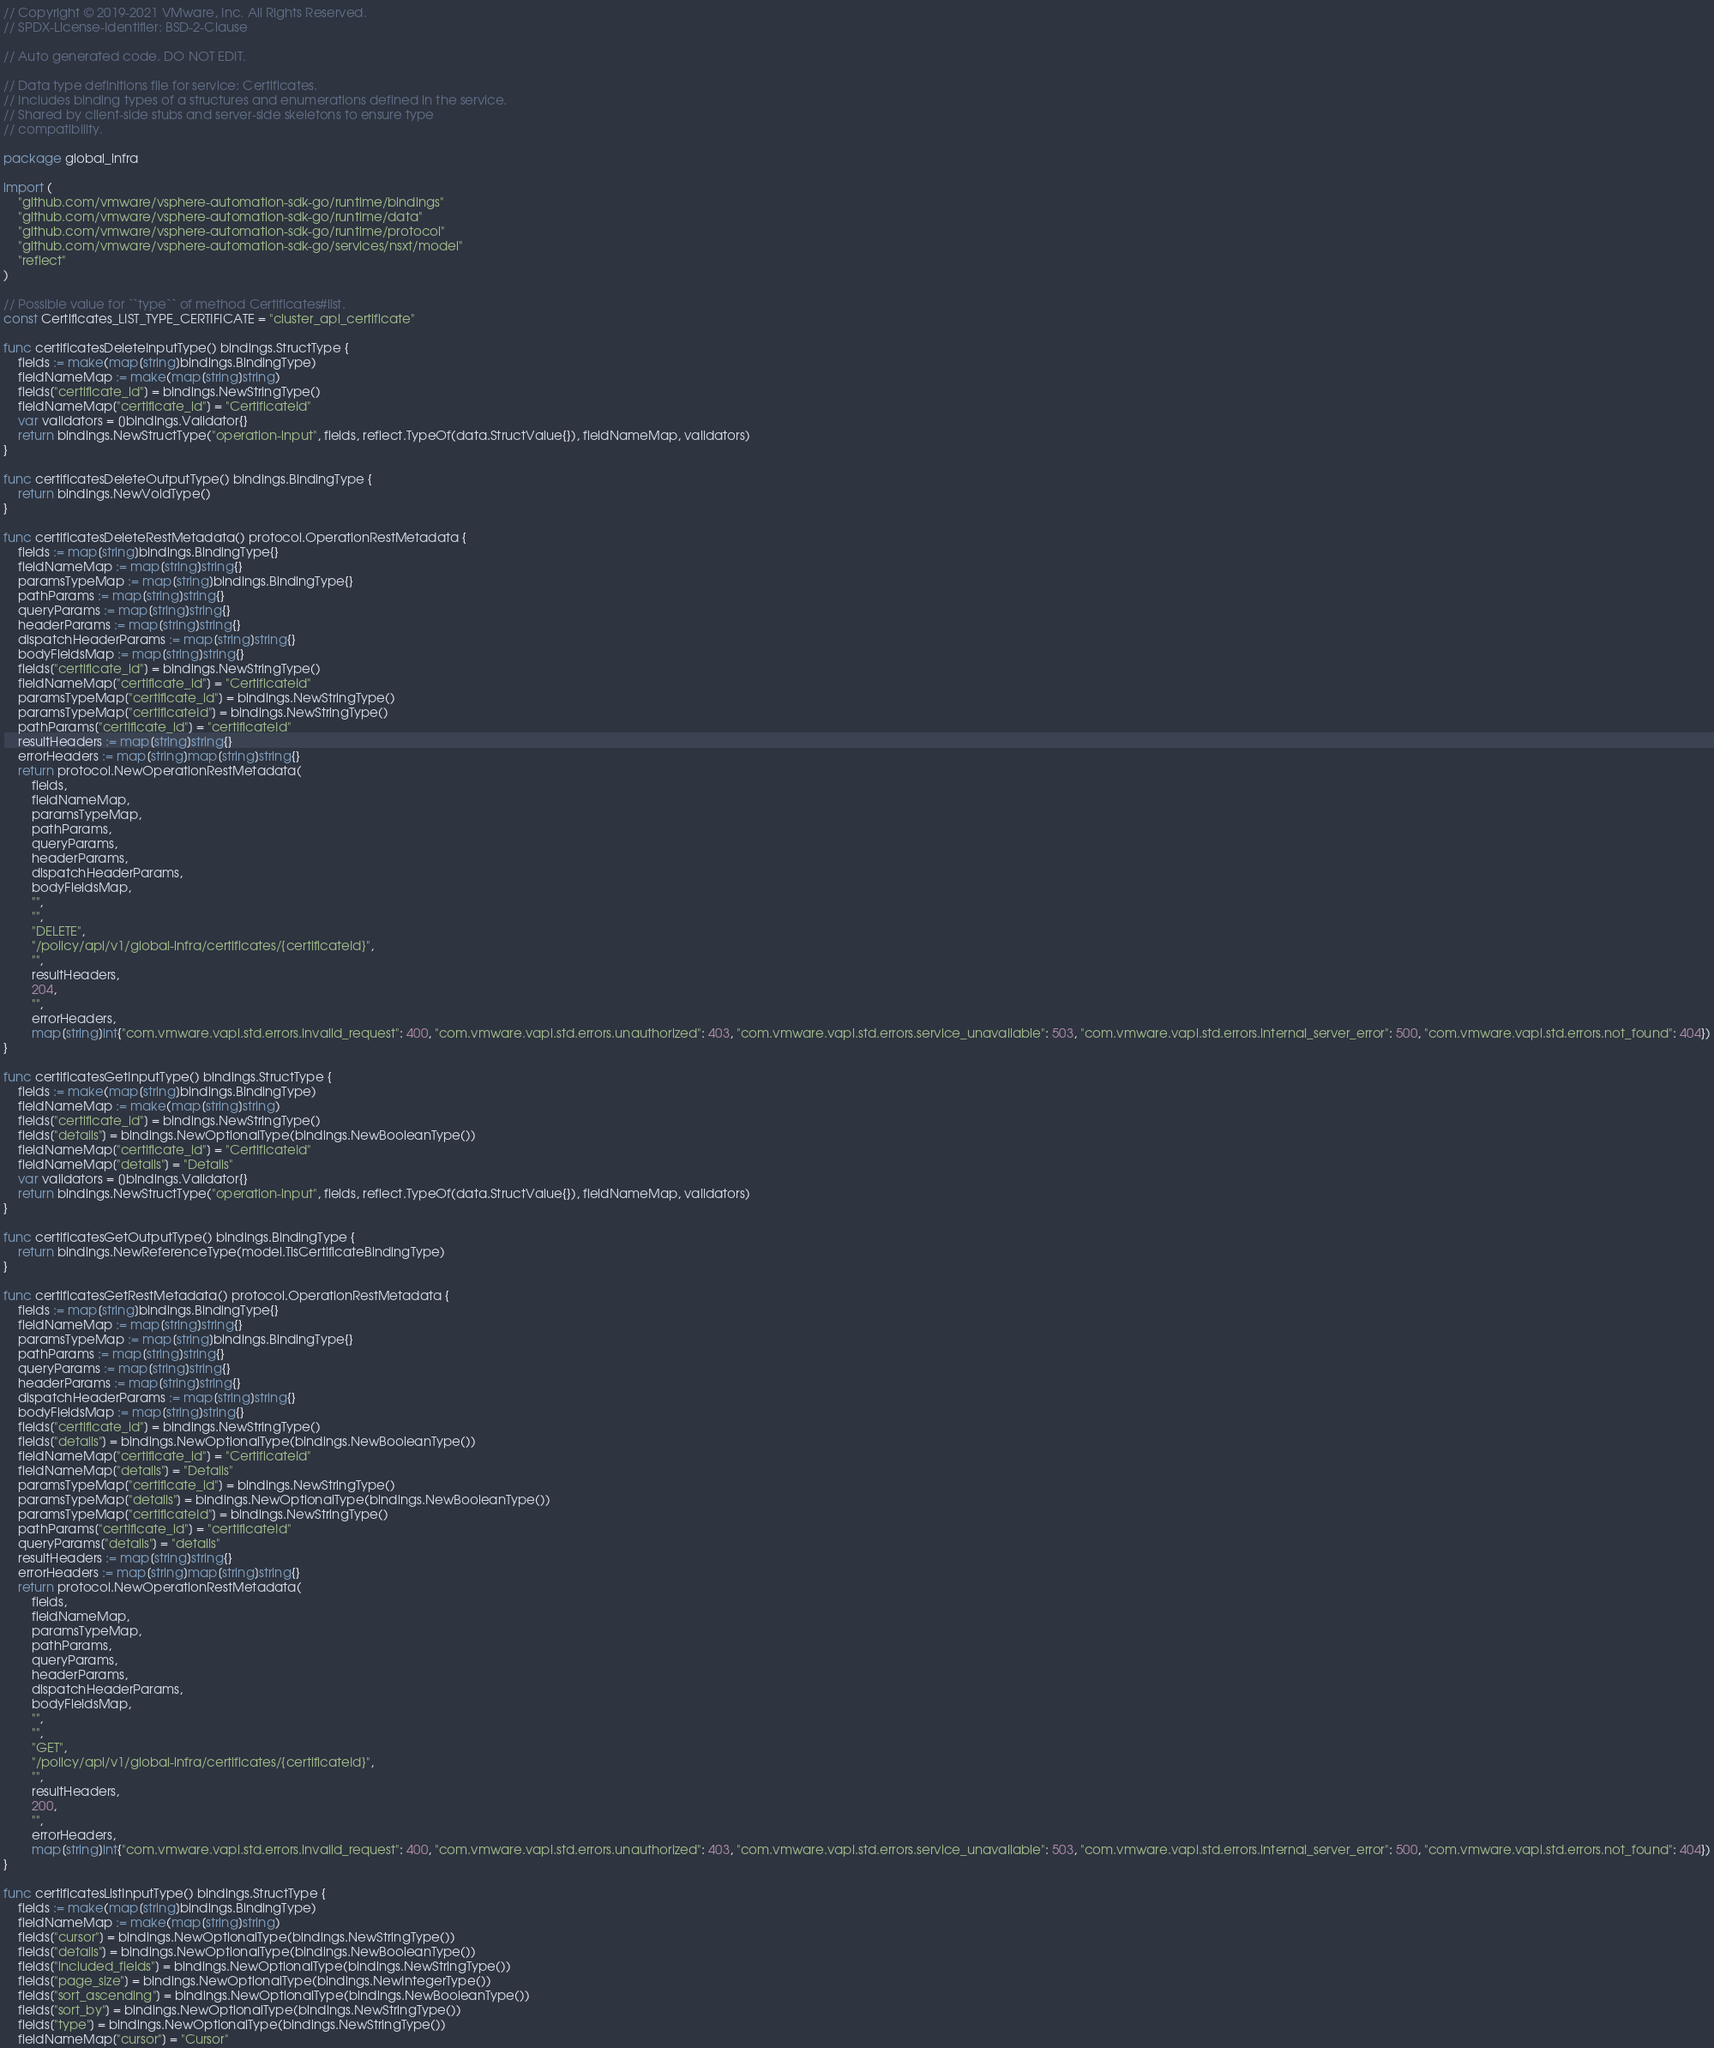Convert code to text. <code><loc_0><loc_0><loc_500><loc_500><_Go_>// Copyright © 2019-2021 VMware, Inc. All Rights Reserved.
// SPDX-License-Identifier: BSD-2-Clause

// Auto generated code. DO NOT EDIT.

// Data type definitions file for service: Certificates.
// Includes binding types of a structures and enumerations defined in the service.
// Shared by client-side stubs and server-side skeletons to ensure type
// compatibility.

package global_infra

import (
	"github.com/vmware/vsphere-automation-sdk-go/runtime/bindings"
	"github.com/vmware/vsphere-automation-sdk-go/runtime/data"
	"github.com/vmware/vsphere-automation-sdk-go/runtime/protocol"
	"github.com/vmware/vsphere-automation-sdk-go/services/nsxt/model"
	"reflect"
)

// Possible value for ``type`` of method Certificates#list.
const Certificates_LIST_TYPE_CERTIFICATE = "cluster_api_certificate"

func certificatesDeleteInputType() bindings.StructType {
	fields := make(map[string]bindings.BindingType)
	fieldNameMap := make(map[string]string)
	fields["certificate_id"] = bindings.NewStringType()
	fieldNameMap["certificate_id"] = "CertificateId"
	var validators = []bindings.Validator{}
	return bindings.NewStructType("operation-input", fields, reflect.TypeOf(data.StructValue{}), fieldNameMap, validators)
}

func certificatesDeleteOutputType() bindings.BindingType {
	return bindings.NewVoidType()
}

func certificatesDeleteRestMetadata() protocol.OperationRestMetadata {
	fields := map[string]bindings.BindingType{}
	fieldNameMap := map[string]string{}
	paramsTypeMap := map[string]bindings.BindingType{}
	pathParams := map[string]string{}
	queryParams := map[string]string{}
	headerParams := map[string]string{}
	dispatchHeaderParams := map[string]string{}
	bodyFieldsMap := map[string]string{}
	fields["certificate_id"] = bindings.NewStringType()
	fieldNameMap["certificate_id"] = "CertificateId"
	paramsTypeMap["certificate_id"] = bindings.NewStringType()
	paramsTypeMap["certificateId"] = bindings.NewStringType()
	pathParams["certificate_id"] = "certificateId"
	resultHeaders := map[string]string{}
	errorHeaders := map[string]map[string]string{}
	return protocol.NewOperationRestMetadata(
		fields,
		fieldNameMap,
		paramsTypeMap,
		pathParams,
		queryParams,
		headerParams,
		dispatchHeaderParams,
		bodyFieldsMap,
		"",
		"",
		"DELETE",
		"/policy/api/v1/global-infra/certificates/{certificateId}",
		"",
		resultHeaders,
		204,
		"",
		errorHeaders,
		map[string]int{"com.vmware.vapi.std.errors.invalid_request": 400, "com.vmware.vapi.std.errors.unauthorized": 403, "com.vmware.vapi.std.errors.service_unavailable": 503, "com.vmware.vapi.std.errors.internal_server_error": 500, "com.vmware.vapi.std.errors.not_found": 404})
}

func certificatesGetInputType() bindings.StructType {
	fields := make(map[string]bindings.BindingType)
	fieldNameMap := make(map[string]string)
	fields["certificate_id"] = bindings.NewStringType()
	fields["details"] = bindings.NewOptionalType(bindings.NewBooleanType())
	fieldNameMap["certificate_id"] = "CertificateId"
	fieldNameMap["details"] = "Details"
	var validators = []bindings.Validator{}
	return bindings.NewStructType("operation-input", fields, reflect.TypeOf(data.StructValue{}), fieldNameMap, validators)
}

func certificatesGetOutputType() bindings.BindingType {
	return bindings.NewReferenceType(model.TlsCertificateBindingType)
}

func certificatesGetRestMetadata() protocol.OperationRestMetadata {
	fields := map[string]bindings.BindingType{}
	fieldNameMap := map[string]string{}
	paramsTypeMap := map[string]bindings.BindingType{}
	pathParams := map[string]string{}
	queryParams := map[string]string{}
	headerParams := map[string]string{}
	dispatchHeaderParams := map[string]string{}
	bodyFieldsMap := map[string]string{}
	fields["certificate_id"] = bindings.NewStringType()
	fields["details"] = bindings.NewOptionalType(bindings.NewBooleanType())
	fieldNameMap["certificate_id"] = "CertificateId"
	fieldNameMap["details"] = "Details"
	paramsTypeMap["certificate_id"] = bindings.NewStringType()
	paramsTypeMap["details"] = bindings.NewOptionalType(bindings.NewBooleanType())
	paramsTypeMap["certificateId"] = bindings.NewStringType()
	pathParams["certificate_id"] = "certificateId"
	queryParams["details"] = "details"
	resultHeaders := map[string]string{}
	errorHeaders := map[string]map[string]string{}
	return protocol.NewOperationRestMetadata(
		fields,
		fieldNameMap,
		paramsTypeMap,
		pathParams,
		queryParams,
		headerParams,
		dispatchHeaderParams,
		bodyFieldsMap,
		"",
		"",
		"GET",
		"/policy/api/v1/global-infra/certificates/{certificateId}",
		"",
		resultHeaders,
		200,
		"",
		errorHeaders,
		map[string]int{"com.vmware.vapi.std.errors.invalid_request": 400, "com.vmware.vapi.std.errors.unauthorized": 403, "com.vmware.vapi.std.errors.service_unavailable": 503, "com.vmware.vapi.std.errors.internal_server_error": 500, "com.vmware.vapi.std.errors.not_found": 404})
}

func certificatesListInputType() bindings.StructType {
	fields := make(map[string]bindings.BindingType)
	fieldNameMap := make(map[string]string)
	fields["cursor"] = bindings.NewOptionalType(bindings.NewStringType())
	fields["details"] = bindings.NewOptionalType(bindings.NewBooleanType())
	fields["included_fields"] = bindings.NewOptionalType(bindings.NewStringType())
	fields["page_size"] = bindings.NewOptionalType(bindings.NewIntegerType())
	fields["sort_ascending"] = bindings.NewOptionalType(bindings.NewBooleanType())
	fields["sort_by"] = bindings.NewOptionalType(bindings.NewStringType())
	fields["type"] = bindings.NewOptionalType(bindings.NewStringType())
	fieldNameMap["cursor"] = "Cursor"</code> 